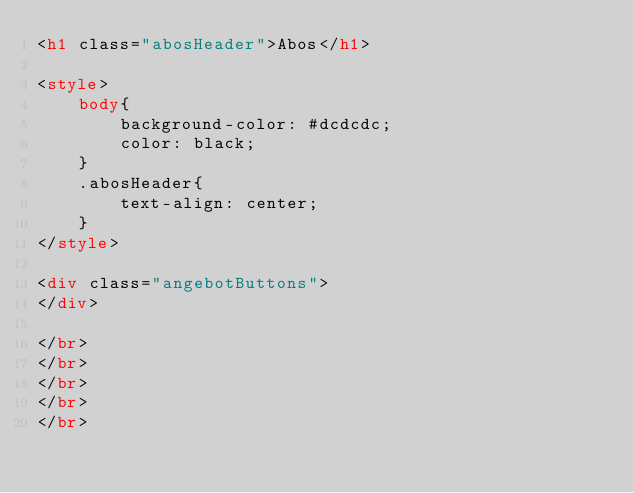Convert code to text. <code><loc_0><loc_0><loc_500><loc_500><_HTML_><h1 class="abosHeader">Abos</h1> 

<style>
    body{
        background-color: #dcdcdc;
        color: black;
    }
    .abosHeader{
        text-align: center;
    }
</style>

<div class="angebotButtons">
</div>

</br>
</br>
</br>
</br>
</br>





</code> 